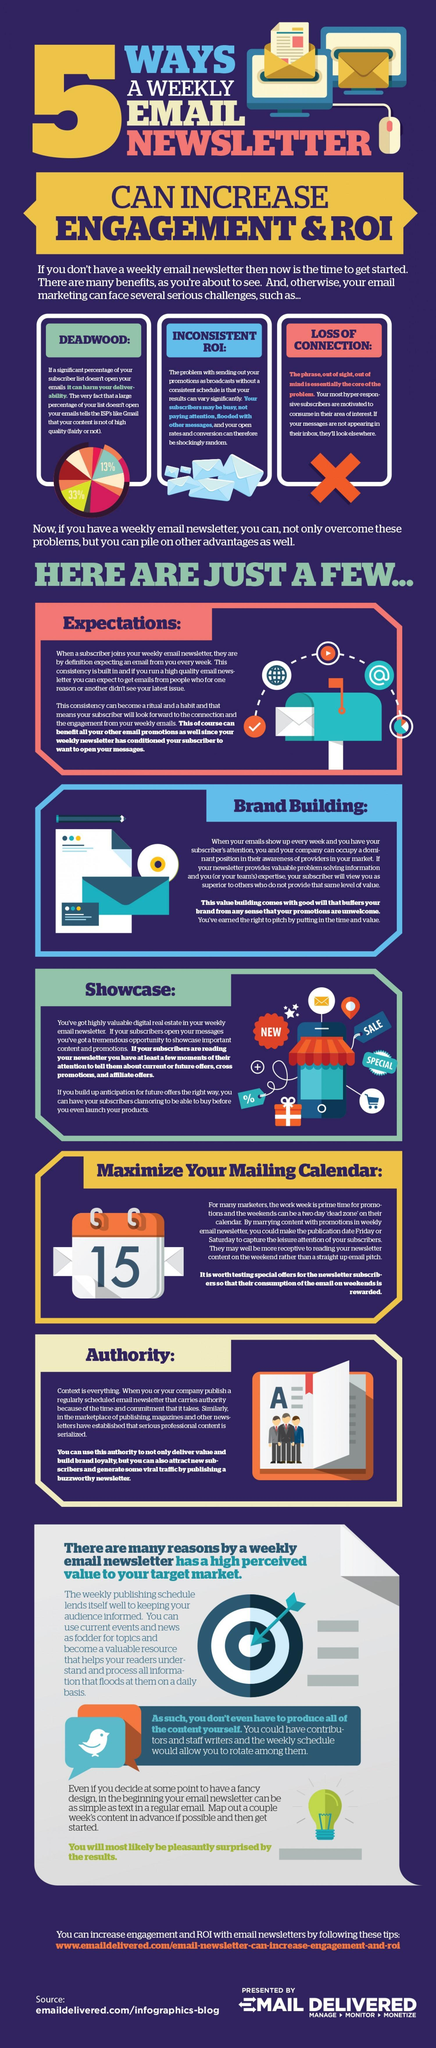What is written on the image of the book?
Answer the question with a short phrase. A How many advantages of weekly email newsletters are mentioned here? 5 What are the first three advantages of weekly email newsletters mentioned? Expectations, brand building, showcase What are the three main challenges faced by email marketing? Deadwood, inconsistent ROI, loss of connection What is written on the image of the calendar? 15 Who else can produce content for your weekly email newsletters? Contributors, staff writers 